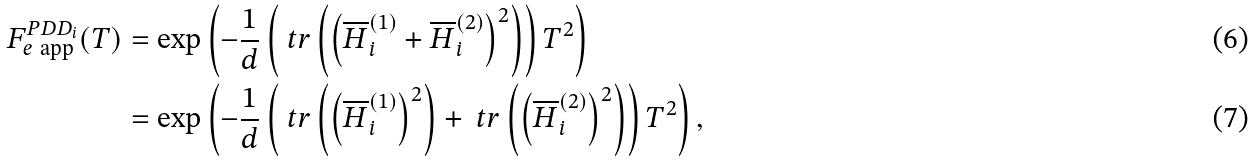<formula> <loc_0><loc_0><loc_500><loc_500>F _ { e \ \text {app} } ^ { P D D _ { i } } ( T ) & = \exp \left ( - \frac { 1 } { d } \left ( \ t r \left ( \left ( \overline { H } _ { i } ^ { ( 1 ) } + \overline { H } _ { i } ^ { ( 2 ) } \right ) ^ { 2 } \right ) \right ) T ^ { 2 } \right ) \\ & = \exp \left ( - \frac { 1 } { d } \left ( \ t r \left ( \left ( \overline { H } _ { i } ^ { ( 1 ) } \right ) ^ { 2 } \right ) + \ t r \left ( \left ( \overline { H } _ { i } ^ { ( 2 ) } \right ) ^ { 2 } \right ) \right ) T ^ { 2 } \right ) ,</formula> 